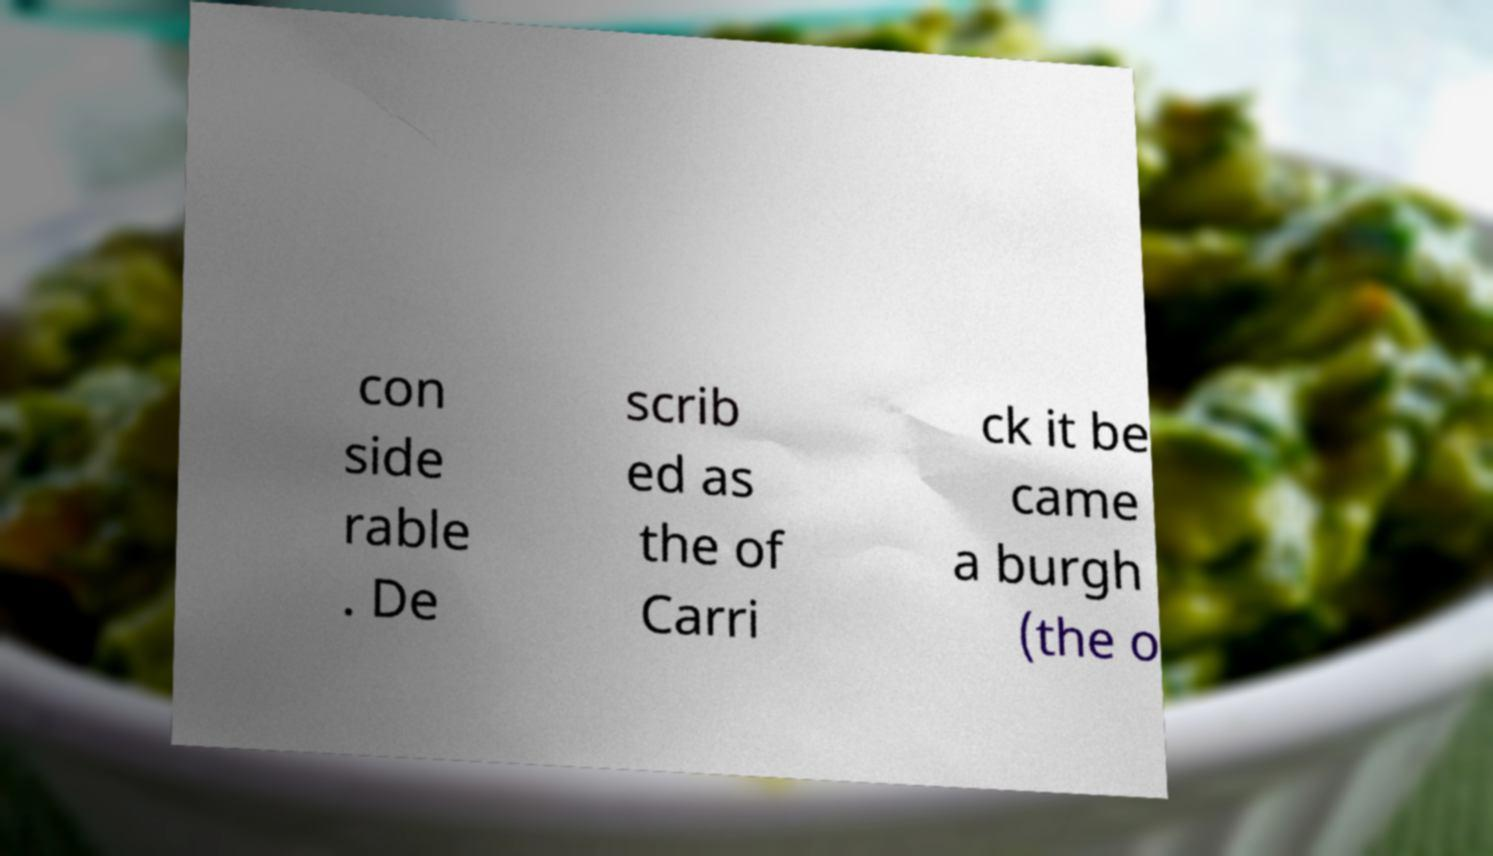For documentation purposes, I need the text within this image transcribed. Could you provide that? con side rable . De scrib ed as the of Carri ck it be came a burgh (the o 